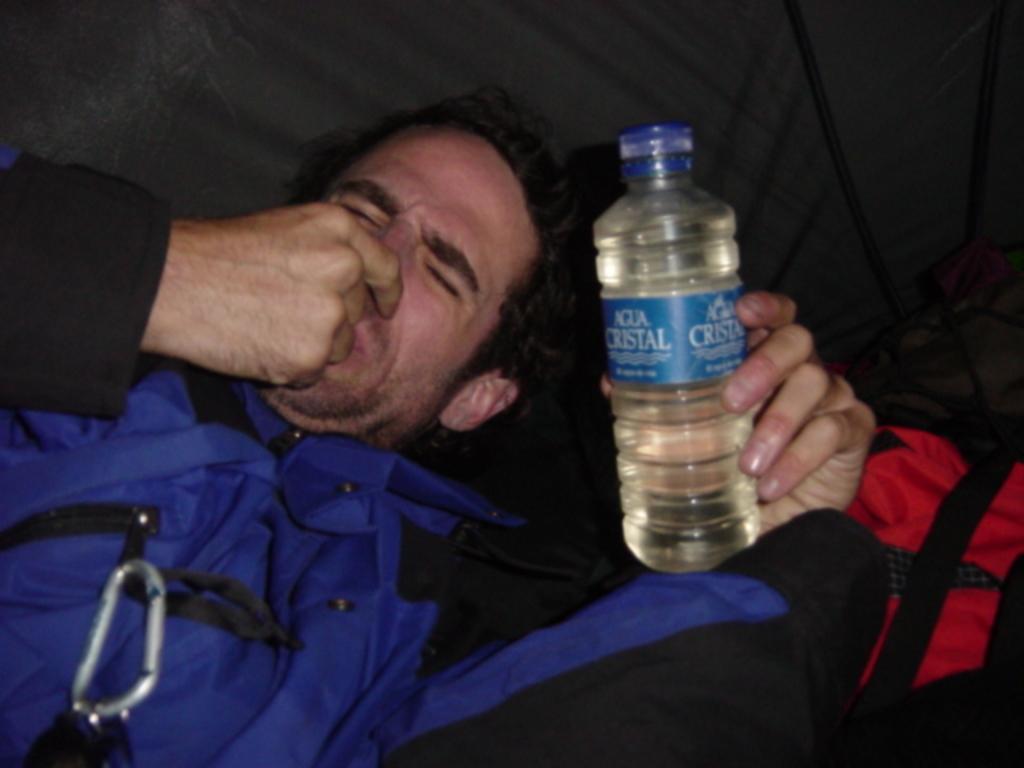Describe this image in one or two sentences. In this image there is a man laying in couch and holding a water bottle, and in back ground there is a bag. 